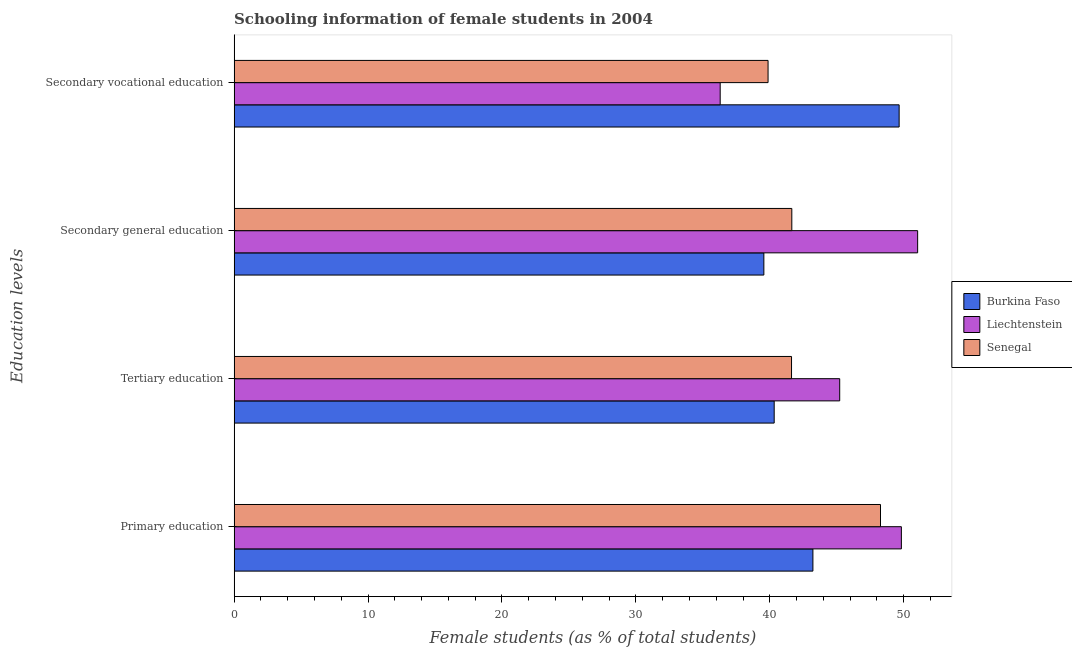How many bars are there on the 4th tick from the top?
Your response must be concise. 3. What is the label of the 2nd group of bars from the top?
Your answer should be compact. Secondary general education. What is the percentage of female students in tertiary education in Burkina Faso?
Keep it short and to the point. 40.33. Across all countries, what is the maximum percentage of female students in secondary vocational education?
Give a very brief answer. 49.66. Across all countries, what is the minimum percentage of female students in tertiary education?
Your answer should be very brief. 40.33. In which country was the percentage of female students in tertiary education maximum?
Offer a terse response. Liechtenstein. In which country was the percentage of female students in secondary vocational education minimum?
Your answer should be very brief. Liechtenstein. What is the total percentage of female students in secondary education in the graph?
Keep it short and to the point. 132.23. What is the difference between the percentage of female students in tertiary education in Burkina Faso and that in Liechtenstein?
Provide a succinct answer. -4.89. What is the difference between the percentage of female students in secondary vocational education in Liechtenstein and the percentage of female students in primary education in Burkina Faso?
Keep it short and to the point. -6.92. What is the average percentage of female students in primary education per country?
Make the answer very short. 47.1. What is the difference between the percentage of female students in secondary education and percentage of female students in primary education in Liechtenstein?
Your answer should be compact. 1.21. What is the ratio of the percentage of female students in secondary education in Senegal to that in Liechtenstein?
Your answer should be compact. 0.82. Is the percentage of female students in secondary vocational education in Liechtenstein less than that in Senegal?
Give a very brief answer. Yes. Is the difference between the percentage of female students in secondary education in Liechtenstein and Senegal greater than the difference between the percentage of female students in secondary vocational education in Liechtenstein and Senegal?
Keep it short and to the point. Yes. What is the difference between the highest and the second highest percentage of female students in tertiary education?
Provide a succinct answer. 3.6. What is the difference between the highest and the lowest percentage of female students in secondary vocational education?
Provide a short and direct response. 13.36. In how many countries, is the percentage of female students in tertiary education greater than the average percentage of female students in tertiary education taken over all countries?
Offer a very short reply. 1. What does the 2nd bar from the top in Secondary general education represents?
Keep it short and to the point. Liechtenstein. What does the 3rd bar from the bottom in Tertiary education represents?
Give a very brief answer. Senegal. Does the graph contain any zero values?
Offer a very short reply. No. Does the graph contain grids?
Keep it short and to the point. No. Where does the legend appear in the graph?
Provide a short and direct response. Center right. What is the title of the graph?
Offer a terse response. Schooling information of female students in 2004. Does "Panama" appear as one of the legend labels in the graph?
Your response must be concise. No. What is the label or title of the X-axis?
Ensure brevity in your answer.  Female students (as % of total students). What is the label or title of the Y-axis?
Ensure brevity in your answer.  Education levels. What is the Female students (as % of total students) in Burkina Faso in Primary education?
Give a very brief answer. 43.22. What is the Female students (as % of total students) of Liechtenstein in Primary education?
Offer a very short reply. 49.82. What is the Female students (as % of total students) in Senegal in Primary education?
Offer a terse response. 48.26. What is the Female students (as % of total students) of Burkina Faso in Tertiary education?
Offer a very short reply. 40.33. What is the Female students (as % of total students) of Liechtenstein in Tertiary education?
Your answer should be compact. 45.22. What is the Female students (as % of total students) of Senegal in Tertiary education?
Give a very brief answer. 41.62. What is the Female students (as % of total students) of Burkina Faso in Secondary general education?
Provide a succinct answer. 39.55. What is the Female students (as % of total students) of Liechtenstein in Secondary general education?
Provide a succinct answer. 51.04. What is the Female students (as % of total students) of Senegal in Secondary general education?
Your answer should be compact. 41.64. What is the Female students (as % of total students) in Burkina Faso in Secondary vocational education?
Offer a very short reply. 49.66. What is the Female students (as % of total students) in Liechtenstein in Secondary vocational education?
Offer a very short reply. 36.29. What is the Female students (as % of total students) in Senegal in Secondary vocational education?
Offer a terse response. 39.87. Across all Education levels, what is the maximum Female students (as % of total students) of Burkina Faso?
Give a very brief answer. 49.66. Across all Education levels, what is the maximum Female students (as % of total students) of Liechtenstein?
Your answer should be very brief. 51.04. Across all Education levels, what is the maximum Female students (as % of total students) in Senegal?
Offer a very short reply. 48.26. Across all Education levels, what is the minimum Female students (as % of total students) of Burkina Faso?
Give a very brief answer. 39.55. Across all Education levels, what is the minimum Female students (as % of total students) of Liechtenstein?
Offer a very short reply. 36.29. Across all Education levels, what is the minimum Female students (as % of total students) of Senegal?
Your response must be concise. 39.87. What is the total Female students (as % of total students) of Burkina Faso in the graph?
Give a very brief answer. 172.76. What is the total Female students (as % of total students) of Liechtenstein in the graph?
Offer a terse response. 182.37. What is the total Female students (as % of total students) of Senegal in the graph?
Your answer should be compact. 171.4. What is the difference between the Female students (as % of total students) of Burkina Faso in Primary education and that in Tertiary education?
Make the answer very short. 2.89. What is the difference between the Female students (as % of total students) of Liechtenstein in Primary education and that in Tertiary education?
Keep it short and to the point. 4.61. What is the difference between the Female students (as % of total students) of Senegal in Primary education and that in Tertiary education?
Provide a succinct answer. 6.64. What is the difference between the Female students (as % of total students) of Burkina Faso in Primary education and that in Secondary general education?
Make the answer very short. 3.66. What is the difference between the Female students (as % of total students) in Liechtenstein in Primary education and that in Secondary general education?
Offer a terse response. -1.21. What is the difference between the Female students (as % of total students) of Senegal in Primary education and that in Secondary general education?
Make the answer very short. 6.62. What is the difference between the Female students (as % of total students) of Burkina Faso in Primary education and that in Secondary vocational education?
Provide a succinct answer. -6.44. What is the difference between the Female students (as % of total students) of Liechtenstein in Primary education and that in Secondary vocational education?
Your answer should be compact. 13.53. What is the difference between the Female students (as % of total students) in Senegal in Primary education and that in Secondary vocational education?
Provide a short and direct response. 8.39. What is the difference between the Female students (as % of total students) in Burkina Faso in Tertiary education and that in Secondary general education?
Ensure brevity in your answer.  0.77. What is the difference between the Female students (as % of total students) in Liechtenstein in Tertiary education and that in Secondary general education?
Keep it short and to the point. -5.82. What is the difference between the Female students (as % of total students) of Senegal in Tertiary education and that in Secondary general education?
Your answer should be compact. -0.02. What is the difference between the Female students (as % of total students) of Burkina Faso in Tertiary education and that in Secondary vocational education?
Your response must be concise. -9.33. What is the difference between the Female students (as % of total students) of Liechtenstein in Tertiary education and that in Secondary vocational education?
Ensure brevity in your answer.  8.92. What is the difference between the Female students (as % of total students) of Senegal in Tertiary education and that in Secondary vocational education?
Offer a terse response. 1.75. What is the difference between the Female students (as % of total students) in Burkina Faso in Secondary general education and that in Secondary vocational education?
Your answer should be compact. -10.1. What is the difference between the Female students (as % of total students) of Liechtenstein in Secondary general education and that in Secondary vocational education?
Your answer should be very brief. 14.74. What is the difference between the Female students (as % of total students) of Senegal in Secondary general education and that in Secondary vocational education?
Provide a succinct answer. 1.77. What is the difference between the Female students (as % of total students) in Burkina Faso in Primary education and the Female students (as % of total students) in Liechtenstein in Tertiary education?
Offer a very short reply. -2. What is the difference between the Female students (as % of total students) in Burkina Faso in Primary education and the Female students (as % of total students) in Senegal in Tertiary education?
Provide a succinct answer. 1.6. What is the difference between the Female students (as % of total students) of Liechtenstein in Primary education and the Female students (as % of total students) of Senegal in Tertiary education?
Offer a terse response. 8.2. What is the difference between the Female students (as % of total students) in Burkina Faso in Primary education and the Female students (as % of total students) in Liechtenstein in Secondary general education?
Provide a succinct answer. -7.82. What is the difference between the Female students (as % of total students) of Burkina Faso in Primary education and the Female students (as % of total students) of Senegal in Secondary general education?
Your answer should be compact. 1.58. What is the difference between the Female students (as % of total students) in Liechtenstein in Primary education and the Female students (as % of total students) in Senegal in Secondary general education?
Give a very brief answer. 8.18. What is the difference between the Female students (as % of total students) in Burkina Faso in Primary education and the Female students (as % of total students) in Liechtenstein in Secondary vocational education?
Provide a short and direct response. 6.92. What is the difference between the Female students (as % of total students) of Burkina Faso in Primary education and the Female students (as % of total students) of Senegal in Secondary vocational education?
Make the answer very short. 3.35. What is the difference between the Female students (as % of total students) in Liechtenstein in Primary education and the Female students (as % of total students) in Senegal in Secondary vocational education?
Ensure brevity in your answer.  9.95. What is the difference between the Female students (as % of total students) of Burkina Faso in Tertiary education and the Female students (as % of total students) of Liechtenstein in Secondary general education?
Provide a short and direct response. -10.71. What is the difference between the Female students (as % of total students) in Burkina Faso in Tertiary education and the Female students (as % of total students) in Senegal in Secondary general education?
Provide a short and direct response. -1.32. What is the difference between the Female students (as % of total students) of Liechtenstein in Tertiary education and the Female students (as % of total students) of Senegal in Secondary general education?
Offer a terse response. 3.58. What is the difference between the Female students (as % of total students) in Burkina Faso in Tertiary education and the Female students (as % of total students) in Liechtenstein in Secondary vocational education?
Your answer should be very brief. 4.03. What is the difference between the Female students (as % of total students) in Burkina Faso in Tertiary education and the Female students (as % of total students) in Senegal in Secondary vocational education?
Provide a short and direct response. 0.46. What is the difference between the Female students (as % of total students) of Liechtenstein in Tertiary education and the Female students (as % of total students) of Senegal in Secondary vocational education?
Keep it short and to the point. 5.35. What is the difference between the Female students (as % of total students) in Burkina Faso in Secondary general education and the Female students (as % of total students) in Liechtenstein in Secondary vocational education?
Provide a succinct answer. 3.26. What is the difference between the Female students (as % of total students) of Burkina Faso in Secondary general education and the Female students (as % of total students) of Senegal in Secondary vocational education?
Provide a short and direct response. -0.31. What is the difference between the Female students (as % of total students) of Liechtenstein in Secondary general education and the Female students (as % of total students) of Senegal in Secondary vocational education?
Keep it short and to the point. 11.17. What is the average Female students (as % of total students) of Burkina Faso per Education levels?
Make the answer very short. 43.19. What is the average Female students (as % of total students) of Liechtenstein per Education levels?
Your answer should be compact. 45.59. What is the average Female students (as % of total students) of Senegal per Education levels?
Make the answer very short. 42.85. What is the difference between the Female students (as % of total students) of Burkina Faso and Female students (as % of total students) of Liechtenstein in Primary education?
Ensure brevity in your answer.  -6.61. What is the difference between the Female students (as % of total students) of Burkina Faso and Female students (as % of total students) of Senegal in Primary education?
Make the answer very short. -5.05. What is the difference between the Female students (as % of total students) of Liechtenstein and Female students (as % of total students) of Senegal in Primary education?
Your answer should be compact. 1.56. What is the difference between the Female students (as % of total students) of Burkina Faso and Female students (as % of total students) of Liechtenstein in Tertiary education?
Provide a short and direct response. -4.89. What is the difference between the Female students (as % of total students) of Burkina Faso and Female students (as % of total students) of Senegal in Tertiary education?
Ensure brevity in your answer.  -1.29. What is the difference between the Female students (as % of total students) in Liechtenstein and Female students (as % of total students) in Senegal in Tertiary education?
Ensure brevity in your answer.  3.6. What is the difference between the Female students (as % of total students) in Burkina Faso and Female students (as % of total students) in Liechtenstein in Secondary general education?
Keep it short and to the point. -11.48. What is the difference between the Female students (as % of total students) of Burkina Faso and Female students (as % of total students) of Senegal in Secondary general education?
Offer a terse response. -2.09. What is the difference between the Female students (as % of total students) in Liechtenstein and Female students (as % of total students) in Senegal in Secondary general education?
Provide a short and direct response. 9.4. What is the difference between the Female students (as % of total students) of Burkina Faso and Female students (as % of total students) of Liechtenstein in Secondary vocational education?
Make the answer very short. 13.36. What is the difference between the Female students (as % of total students) of Burkina Faso and Female students (as % of total students) of Senegal in Secondary vocational education?
Your answer should be very brief. 9.79. What is the difference between the Female students (as % of total students) in Liechtenstein and Female students (as % of total students) in Senegal in Secondary vocational education?
Make the answer very short. -3.58. What is the ratio of the Female students (as % of total students) of Burkina Faso in Primary education to that in Tertiary education?
Ensure brevity in your answer.  1.07. What is the ratio of the Female students (as % of total students) of Liechtenstein in Primary education to that in Tertiary education?
Provide a succinct answer. 1.1. What is the ratio of the Female students (as % of total students) of Senegal in Primary education to that in Tertiary education?
Give a very brief answer. 1.16. What is the ratio of the Female students (as % of total students) in Burkina Faso in Primary education to that in Secondary general education?
Make the answer very short. 1.09. What is the ratio of the Female students (as % of total students) of Liechtenstein in Primary education to that in Secondary general education?
Keep it short and to the point. 0.98. What is the ratio of the Female students (as % of total students) in Senegal in Primary education to that in Secondary general education?
Your response must be concise. 1.16. What is the ratio of the Female students (as % of total students) in Burkina Faso in Primary education to that in Secondary vocational education?
Ensure brevity in your answer.  0.87. What is the ratio of the Female students (as % of total students) in Liechtenstein in Primary education to that in Secondary vocational education?
Offer a terse response. 1.37. What is the ratio of the Female students (as % of total students) of Senegal in Primary education to that in Secondary vocational education?
Offer a very short reply. 1.21. What is the ratio of the Female students (as % of total students) in Burkina Faso in Tertiary education to that in Secondary general education?
Keep it short and to the point. 1.02. What is the ratio of the Female students (as % of total students) in Liechtenstein in Tertiary education to that in Secondary general education?
Provide a succinct answer. 0.89. What is the ratio of the Female students (as % of total students) of Senegal in Tertiary education to that in Secondary general education?
Provide a succinct answer. 1. What is the ratio of the Female students (as % of total students) in Burkina Faso in Tertiary education to that in Secondary vocational education?
Ensure brevity in your answer.  0.81. What is the ratio of the Female students (as % of total students) of Liechtenstein in Tertiary education to that in Secondary vocational education?
Ensure brevity in your answer.  1.25. What is the ratio of the Female students (as % of total students) in Senegal in Tertiary education to that in Secondary vocational education?
Provide a short and direct response. 1.04. What is the ratio of the Female students (as % of total students) in Burkina Faso in Secondary general education to that in Secondary vocational education?
Ensure brevity in your answer.  0.8. What is the ratio of the Female students (as % of total students) of Liechtenstein in Secondary general education to that in Secondary vocational education?
Offer a terse response. 1.41. What is the ratio of the Female students (as % of total students) of Senegal in Secondary general education to that in Secondary vocational education?
Your response must be concise. 1.04. What is the difference between the highest and the second highest Female students (as % of total students) of Burkina Faso?
Make the answer very short. 6.44. What is the difference between the highest and the second highest Female students (as % of total students) of Liechtenstein?
Give a very brief answer. 1.21. What is the difference between the highest and the second highest Female students (as % of total students) of Senegal?
Offer a terse response. 6.62. What is the difference between the highest and the lowest Female students (as % of total students) of Burkina Faso?
Provide a succinct answer. 10.1. What is the difference between the highest and the lowest Female students (as % of total students) in Liechtenstein?
Make the answer very short. 14.74. What is the difference between the highest and the lowest Female students (as % of total students) in Senegal?
Provide a short and direct response. 8.39. 